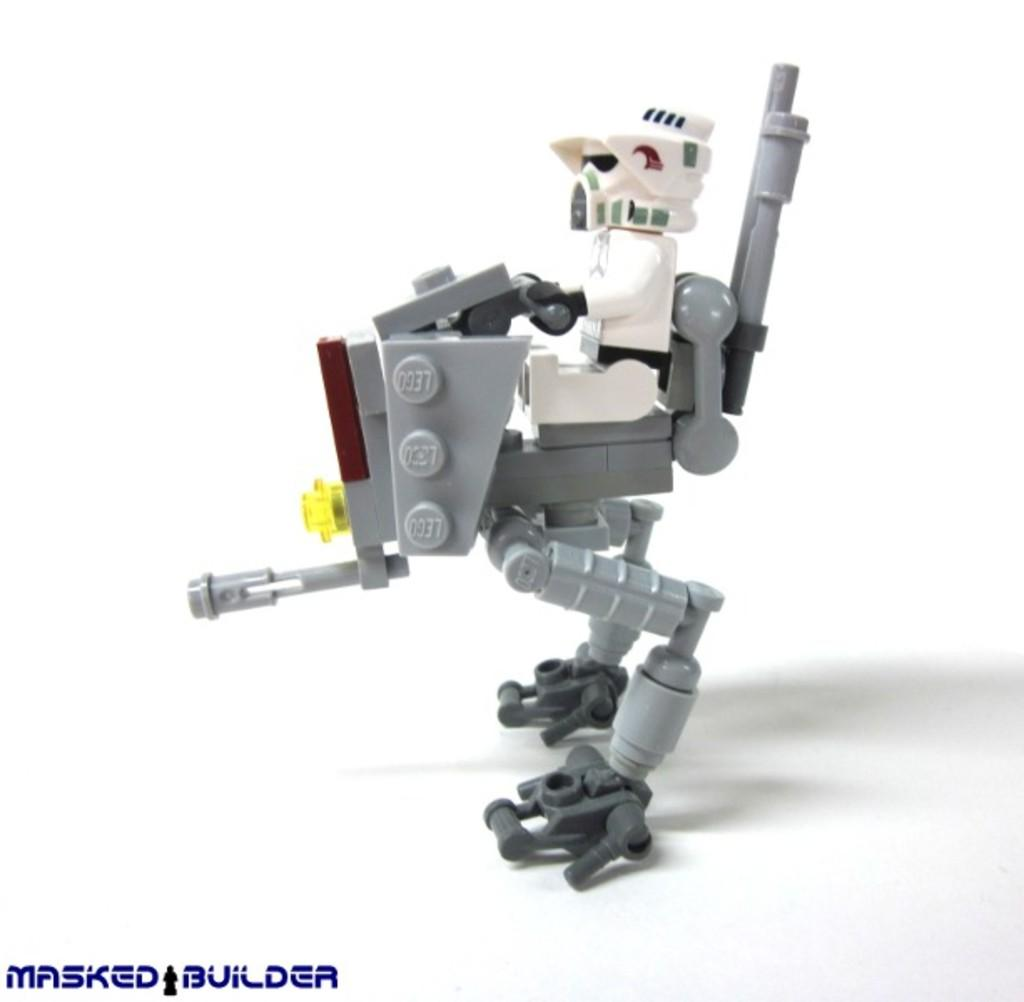What can you describe the toy in the image? There is a toy in the image, but the specific details cannot be determined without more information. What does the text at the bottom of the image say? The text at the bottom of the image cannot be read without more information about its content or language. How many quarters can be seen on the fan in the image? There is no fan or quarters present in the image. What subject is being taught in the image? There is no teaching or subject matter depicted in the image. 